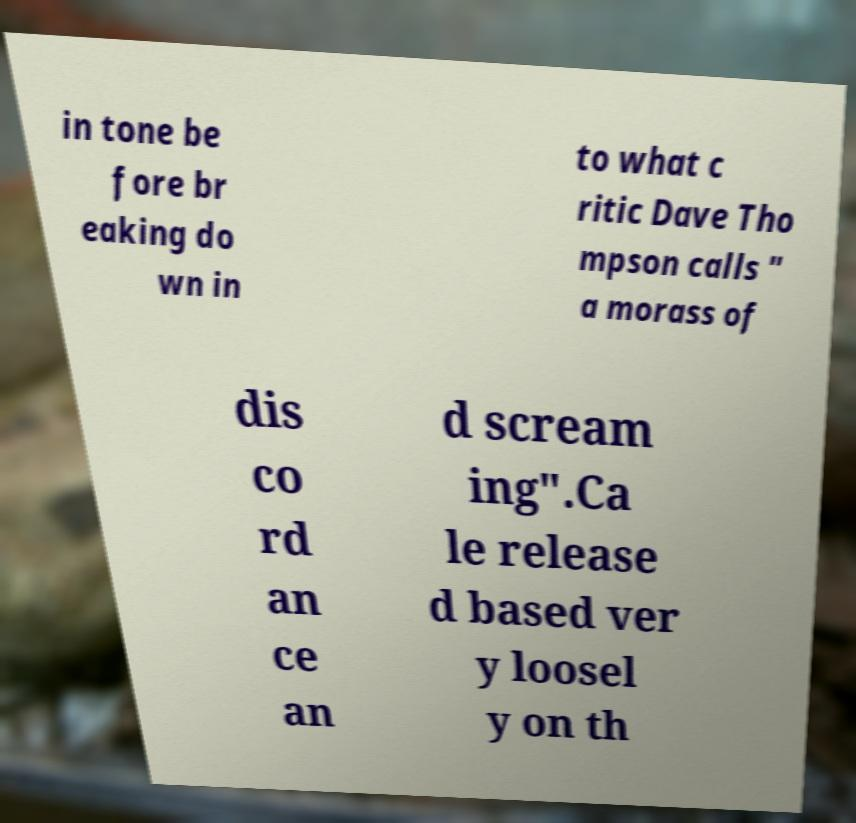There's text embedded in this image that I need extracted. Can you transcribe it verbatim? in tone be fore br eaking do wn in to what c ritic Dave Tho mpson calls " a morass of dis co rd an ce an d scream ing".Ca le release d based ver y loosel y on th 